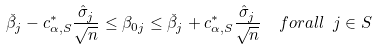<formula> <loc_0><loc_0><loc_500><loc_500>\check { \beta } _ { j } - c _ { \alpha , S } ^ { * } \frac { \hat { \sigma } _ { j } } { \sqrt { n } } \leq \beta _ { 0 j } \leq \check { \beta } _ { j } + c _ { \alpha , S } ^ { * } \frac { \hat { \sigma } _ { j } } { \sqrt { n } } \ \ f o r a l l \ j \in S</formula> 